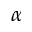<formula> <loc_0><loc_0><loc_500><loc_500>\alpha</formula> 